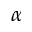<formula> <loc_0><loc_0><loc_500><loc_500>\alpha</formula> 